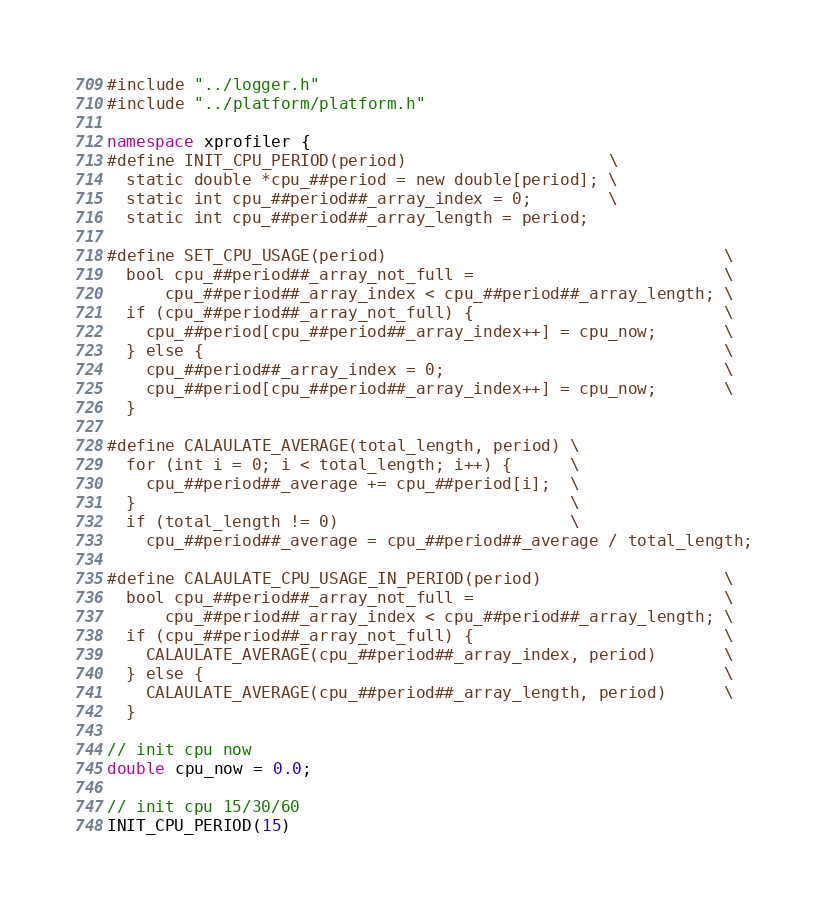Convert code to text. <code><loc_0><loc_0><loc_500><loc_500><_C++_>#include "../logger.h"
#include "../platform/platform.h"

namespace xprofiler {
#define INIT_CPU_PERIOD(period)                     \
  static double *cpu_##period = new double[period]; \
  static int cpu_##period##_array_index = 0;        \
  static int cpu_##period##_array_length = period;

#define SET_CPU_USAGE(period)                                   \
  bool cpu_##period##_array_not_full =                          \
      cpu_##period##_array_index < cpu_##period##_array_length; \
  if (cpu_##period##_array_not_full) {                          \
    cpu_##period[cpu_##period##_array_index++] = cpu_now;       \
  } else {                                                      \
    cpu_##period##_array_index = 0;                             \
    cpu_##period[cpu_##period##_array_index++] = cpu_now;       \
  }

#define CALAULATE_AVERAGE(total_length, period) \
  for (int i = 0; i < total_length; i++) {      \
    cpu_##period##_average += cpu_##period[i];  \
  }                                             \
  if (total_length != 0)                        \
    cpu_##period##_average = cpu_##period##_average / total_length;

#define CALAULATE_CPU_USAGE_IN_PERIOD(period)                   \
  bool cpu_##period##_array_not_full =                          \
      cpu_##period##_array_index < cpu_##period##_array_length; \
  if (cpu_##period##_array_not_full) {                          \
    CALAULATE_AVERAGE(cpu_##period##_array_index, period)       \
  } else {                                                      \
    CALAULATE_AVERAGE(cpu_##period##_array_length, period)      \
  }

// init cpu now
double cpu_now = 0.0;

// init cpu 15/30/60
INIT_CPU_PERIOD(15)</code> 